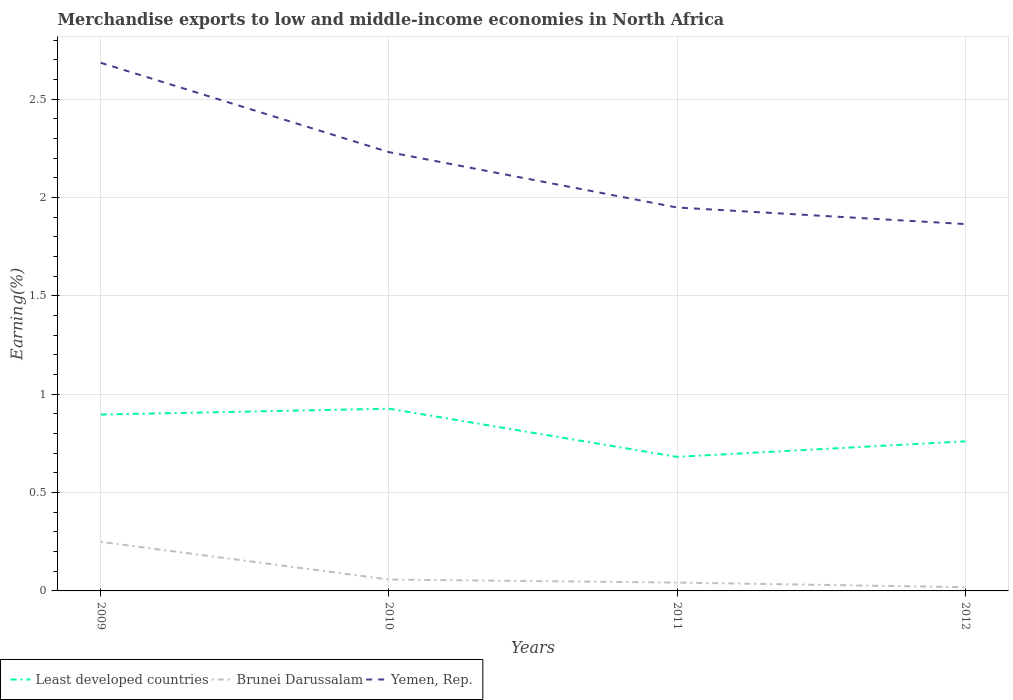How many different coloured lines are there?
Make the answer very short. 3. Does the line corresponding to Brunei Darussalam intersect with the line corresponding to Least developed countries?
Your response must be concise. No. Across all years, what is the maximum percentage of amount earned from merchandise exports in Yemen, Rep.?
Offer a very short reply. 1.87. What is the total percentage of amount earned from merchandise exports in Yemen, Rep. in the graph?
Your answer should be compact. 0.82. What is the difference between the highest and the second highest percentage of amount earned from merchandise exports in Least developed countries?
Make the answer very short. 0.24. What is the difference between the highest and the lowest percentage of amount earned from merchandise exports in Least developed countries?
Give a very brief answer. 2. How many lines are there?
Ensure brevity in your answer.  3. How many years are there in the graph?
Ensure brevity in your answer.  4. What is the difference between two consecutive major ticks on the Y-axis?
Make the answer very short. 0.5. Are the values on the major ticks of Y-axis written in scientific E-notation?
Offer a very short reply. No. Where does the legend appear in the graph?
Provide a succinct answer. Bottom left. What is the title of the graph?
Ensure brevity in your answer.  Merchandise exports to low and middle-income economies in North Africa. What is the label or title of the X-axis?
Offer a terse response. Years. What is the label or title of the Y-axis?
Provide a short and direct response. Earning(%). What is the Earning(%) of Least developed countries in 2009?
Provide a short and direct response. 0.9. What is the Earning(%) of Brunei Darussalam in 2009?
Your answer should be very brief. 0.25. What is the Earning(%) of Yemen, Rep. in 2009?
Offer a terse response. 2.69. What is the Earning(%) of Least developed countries in 2010?
Ensure brevity in your answer.  0.93. What is the Earning(%) of Brunei Darussalam in 2010?
Your answer should be very brief. 0.06. What is the Earning(%) of Yemen, Rep. in 2010?
Ensure brevity in your answer.  2.23. What is the Earning(%) of Least developed countries in 2011?
Provide a short and direct response. 0.68. What is the Earning(%) of Brunei Darussalam in 2011?
Offer a very short reply. 0.04. What is the Earning(%) in Yemen, Rep. in 2011?
Provide a short and direct response. 1.95. What is the Earning(%) of Least developed countries in 2012?
Offer a terse response. 0.76. What is the Earning(%) in Brunei Darussalam in 2012?
Keep it short and to the point. 0.02. What is the Earning(%) in Yemen, Rep. in 2012?
Ensure brevity in your answer.  1.87. Across all years, what is the maximum Earning(%) in Least developed countries?
Ensure brevity in your answer.  0.93. Across all years, what is the maximum Earning(%) in Brunei Darussalam?
Give a very brief answer. 0.25. Across all years, what is the maximum Earning(%) in Yemen, Rep.?
Give a very brief answer. 2.69. Across all years, what is the minimum Earning(%) in Least developed countries?
Keep it short and to the point. 0.68. Across all years, what is the minimum Earning(%) of Brunei Darussalam?
Ensure brevity in your answer.  0.02. Across all years, what is the minimum Earning(%) of Yemen, Rep.?
Provide a short and direct response. 1.87. What is the total Earning(%) in Least developed countries in the graph?
Provide a succinct answer. 3.27. What is the total Earning(%) in Brunei Darussalam in the graph?
Keep it short and to the point. 0.37. What is the total Earning(%) in Yemen, Rep. in the graph?
Your answer should be compact. 8.73. What is the difference between the Earning(%) in Least developed countries in 2009 and that in 2010?
Ensure brevity in your answer.  -0.03. What is the difference between the Earning(%) in Brunei Darussalam in 2009 and that in 2010?
Your answer should be compact. 0.19. What is the difference between the Earning(%) of Yemen, Rep. in 2009 and that in 2010?
Provide a succinct answer. 0.45. What is the difference between the Earning(%) in Least developed countries in 2009 and that in 2011?
Ensure brevity in your answer.  0.22. What is the difference between the Earning(%) of Brunei Darussalam in 2009 and that in 2011?
Offer a terse response. 0.21. What is the difference between the Earning(%) of Yemen, Rep. in 2009 and that in 2011?
Your answer should be compact. 0.74. What is the difference between the Earning(%) of Least developed countries in 2009 and that in 2012?
Your response must be concise. 0.14. What is the difference between the Earning(%) in Brunei Darussalam in 2009 and that in 2012?
Ensure brevity in your answer.  0.23. What is the difference between the Earning(%) in Yemen, Rep. in 2009 and that in 2012?
Your answer should be very brief. 0.82. What is the difference between the Earning(%) in Least developed countries in 2010 and that in 2011?
Provide a short and direct response. 0.24. What is the difference between the Earning(%) in Brunei Darussalam in 2010 and that in 2011?
Give a very brief answer. 0.02. What is the difference between the Earning(%) in Yemen, Rep. in 2010 and that in 2011?
Offer a terse response. 0.28. What is the difference between the Earning(%) in Least developed countries in 2010 and that in 2012?
Keep it short and to the point. 0.17. What is the difference between the Earning(%) in Brunei Darussalam in 2010 and that in 2012?
Provide a succinct answer. 0.04. What is the difference between the Earning(%) of Yemen, Rep. in 2010 and that in 2012?
Offer a very short reply. 0.37. What is the difference between the Earning(%) in Least developed countries in 2011 and that in 2012?
Your answer should be compact. -0.08. What is the difference between the Earning(%) of Brunei Darussalam in 2011 and that in 2012?
Offer a terse response. 0.02. What is the difference between the Earning(%) of Yemen, Rep. in 2011 and that in 2012?
Provide a short and direct response. 0.08. What is the difference between the Earning(%) in Least developed countries in 2009 and the Earning(%) in Brunei Darussalam in 2010?
Ensure brevity in your answer.  0.84. What is the difference between the Earning(%) in Least developed countries in 2009 and the Earning(%) in Yemen, Rep. in 2010?
Keep it short and to the point. -1.33. What is the difference between the Earning(%) in Brunei Darussalam in 2009 and the Earning(%) in Yemen, Rep. in 2010?
Provide a succinct answer. -1.98. What is the difference between the Earning(%) in Least developed countries in 2009 and the Earning(%) in Brunei Darussalam in 2011?
Keep it short and to the point. 0.85. What is the difference between the Earning(%) of Least developed countries in 2009 and the Earning(%) of Yemen, Rep. in 2011?
Make the answer very short. -1.05. What is the difference between the Earning(%) in Brunei Darussalam in 2009 and the Earning(%) in Yemen, Rep. in 2011?
Offer a very short reply. -1.7. What is the difference between the Earning(%) of Least developed countries in 2009 and the Earning(%) of Brunei Darussalam in 2012?
Offer a terse response. 0.88. What is the difference between the Earning(%) in Least developed countries in 2009 and the Earning(%) in Yemen, Rep. in 2012?
Your answer should be compact. -0.97. What is the difference between the Earning(%) of Brunei Darussalam in 2009 and the Earning(%) of Yemen, Rep. in 2012?
Provide a short and direct response. -1.62. What is the difference between the Earning(%) of Least developed countries in 2010 and the Earning(%) of Brunei Darussalam in 2011?
Your answer should be compact. 0.88. What is the difference between the Earning(%) in Least developed countries in 2010 and the Earning(%) in Yemen, Rep. in 2011?
Provide a succinct answer. -1.02. What is the difference between the Earning(%) in Brunei Darussalam in 2010 and the Earning(%) in Yemen, Rep. in 2011?
Offer a very short reply. -1.89. What is the difference between the Earning(%) in Least developed countries in 2010 and the Earning(%) in Brunei Darussalam in 2012?
Ensure brevity in your answer.  0.91. What is the difference between the Earning(%) of Least developed countries in 2010 and the Earning(%) of Yemen, Rep. in 2012?
Provide a succinct answer. -0.94. What is the difference between the Earning(%) in Brunei Darussalam in 2010 and the Earning(%) in Yemen, Rep. in 2012?
Offer a very short reply. -1.81. What is the difference between the Earning(%) in Least developed countries in 2011 and the Earning(%) in Brunei Darussalam in 2012?
Keep it short and to the point. 0.66. What is the difference between the Earning(%) of Least developed countries in 2011 and the Earning(%) of Yemen, Rep. in 2012?
Offer a terse response. -1.18. What is the difference between the Earning(%) in Brunei Darussalam in 2011 and the Earning(%) in Yemen, Rep. in 2012?
Make the answer very short. -1.82. What is the average Earning(%) in Least developed countries per year?
Offer a very short reply. 0.82. What is the average Earning(%) in Brunei Darussalam per year?
Provide a short and direct response. 0.09. What is the average Earning(%) of Yemen, Rep. per year?
Your answer should be very brief. 2.18. In the year 2009, what is the difference between the Earning(%) of Least developed countries and Earning(%) of Brunei Darussalam?
Offer a very short reply. 0.65. In the year 2009, what is the difference between the Earning(%) in Least developed countries and Earning(%) in Yemen, Rep.?
Offer a terse response. -1.79. In the year 2009, what is the difference between the Earning(%) of Brunei Darussalam and Earning(%) of Yemen, Rep.?
Your answer should be compact. -2.44. In the year 2010, what is the difference between the Earning(%) in Least developed countries and Earning(%) in Brunei Darussalam?
Your answer should be compact. 0.87. In the year 2010, what is the difference between the Earning(%) of Least developed countries and Earning(%) of Yemen, Rep.?
Ensure brevity in your answer.  -1.3. In the year 2010, what is the difference between the Earning(%) of Brunei Darussalam and Earning(%) of Yemen, Rep.?
Make the answer very short. -2.17. In the year 2011, what is the difference between the Earning(%) of Least developed countries and Earning(%) of Brunei Darussalam?
Provide a short and direct response. 0.64. In the year 2011, what is the difference between the Earning(%) of Least developed countries and Earning(%) of Yemen, Rep.?
Make the answer very short. -1.27. In the year 2011, what is the difference between the Earning(%) of Brunei Darussalam and Earning(%) of Yemen, Rep.?
Offer a very short reply. -1.91. In the year 2012, what is the difference between the Earning(%) in Least developed countries and Earning(%) in Brunei Darussalam?
Provide a succinct answer. 0.74. In the year 2012, what is the difference between the Earning(%) in Least developed countries and Earning(%) in Yemen, Rep.?
Your answer should be very brief. -1.1. In the year 2012, what is the difference between the Earning(%) in Brunei Darussalam and Earning(%) in Yemen, Rep.?
Provide a short and direct response. -1.85. What is the ratio of the Earning(%) in Least developed countries in 2009 to that in 2010?
Give a very brief answer. 0.97. What is the ratio of the Earning(%) in Brunei Darussalam in 2009 to that in 2010?
Your answer should be compact. 4.31. What is the ratio of the Earning(%) of Yemen, Rep. in 2009 to that in 2010?
Offer a terse response. 1.2. What is the ratio of the Earning(%) of Least developed countries in 2009 to that in 2011?
Provide a short and direct response. 1.32. What is the ratio of the Earning(%) of Brunei Darussalam in 2009 to that in 2011?
Offer a very short reply. 5.88. What is the ratio of the Earning(%) of Yemen, Rep. in 2009 to that in 2011?
Make the answer very short. 1.38. What is the ratio of the Earning(%) of Least developed countries in 2009 to that in 2012?
Offer a terse response. 1.18. What is the ratio of the Earning(%) in Brunei Darussalam in 2009 to that in 2012?
Your response must be concise. 13.16. What is the ratio of the Earning(%) in Yemen, Rep. in 2009 to that in 2012?
Your response must be concise. 1.44. What is the ratio of the Earning(%) of Least developed countries in 2010 to that in 2011?
Offer a very short reply. 1.36. What is the ratio of the Earning(%) in Brunei Darussalam in 2010 to that in 2011?
Provide a succinct answer. 1.36. What is the ratio of the Earning(%) of Yemen, Rep. in 2010 to that in 2011?
Keep it short and to the point. 1.14. What is the ratio of the Earning(%) in Least developed countries in 2010 to that in 2012?
Ensure brevity in your answer.  1.22. What is the ratio of the Earning(%) in Brunei Darussalam in 2010 to that in 2012?
Ensure brevity in your answer.  3.05. What is the ratio of the Earning(%) of Yemen, Rep. in 2010 to that in 2012?
Keep it short and to the point. 1.2. What is the ratio of the Earning(%) of Least developed countries in 2011 to that in 2012?
Your response must be concise. 0.9. What is the ratio of the Earning(%) of Brunei Darussalam in 2011 to that in 2012?
Provide a succinct answer. 2.24. What is the ratio of the Earning(%) of Yemen, Rep. in 2011 to that in 2012?
Your response must be concise. 1.05. What is the difference between the highest and the second highest Earning(%) of Least developed countries?
Offer a terse response. 0.03. What is the difference between the highest and the second highest Earning(%) of Brunei Darussalam?
Your answer should be very brief. 0.19. What is the difference between the highest and the second highest Earning(%) in Yemen, Rep.?
Provide a short and direct response. 0.45. What is the difference between the highest and the lowest Earning(%) in Least developed countries?
Your answer should be compact. 0.24. What is the difference between the highest and the lowest Earning(%) of Brunei Darussalam?
Make the answer very short. 0.23. What is the difference between the highest and the lowest Earning(%) of Yemen, Rep.?
Give a very brief answer. 0.82. 